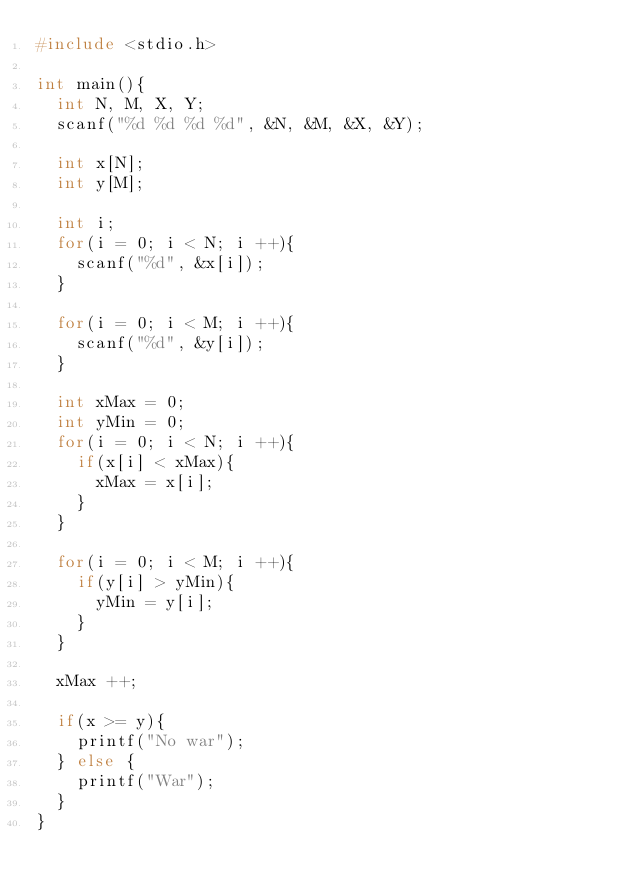<code> <loc_0><loc_0><loc_500><loc_500><_C_>#include <stdio.h>

int main(){
  int N, M, X, Y;
  scanf("%d %d %d %d", &N, &M, &X, &Y);
  
  int x[N];
  int y[M];
  
  int i;
  for(i = 0; i < N; i ++){
    scanf("%d", &x[i]);
  }
  
  for(i = 0; i < M; i ++){
    scanf("%d", &y[i]);
  }
  
  int xMax = 0;
  int yMin = 0;
  for(i = 0; i < N; i ++){
    if(x[i] < xMax){
      xMax = x[i];
    }
  }
  
  for(i = 0; i < M; i ++){
    if(y[i] > yMin){
      yMin = y[i];
    }
  }
  
  xMax ++;
  
  if(x >= y){
    printf("No war");
  } else {
    printf("War");
  }
}

</code> 